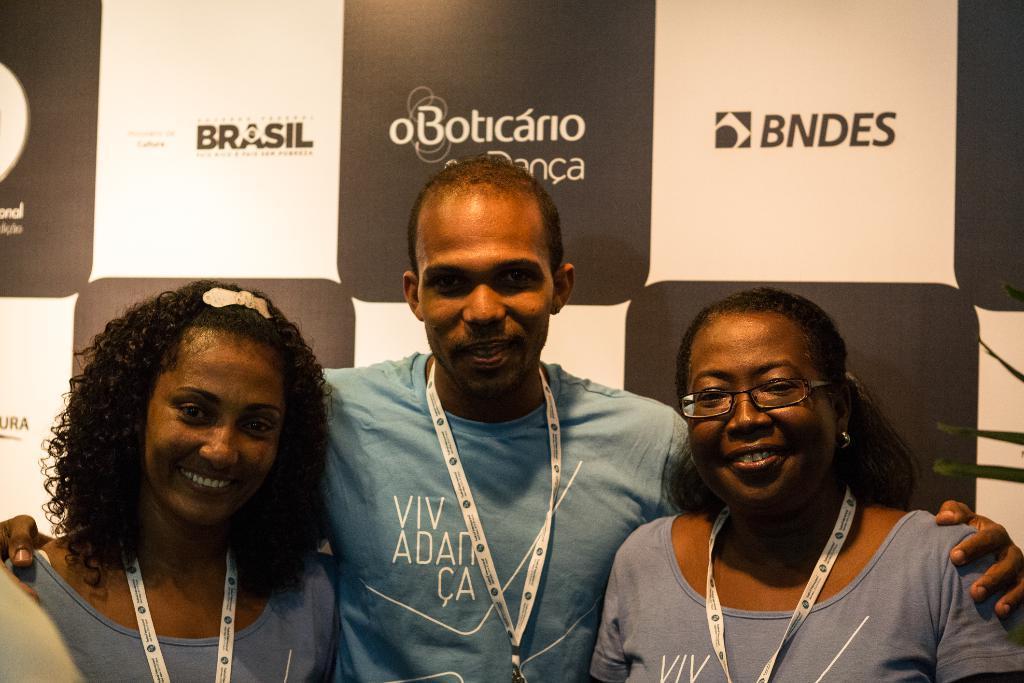How would you summarize this image in a sentence or two? This image consists of three persons. They are wearing the tags. In the background, we can see a banner along with the text. There are two women and a man. 